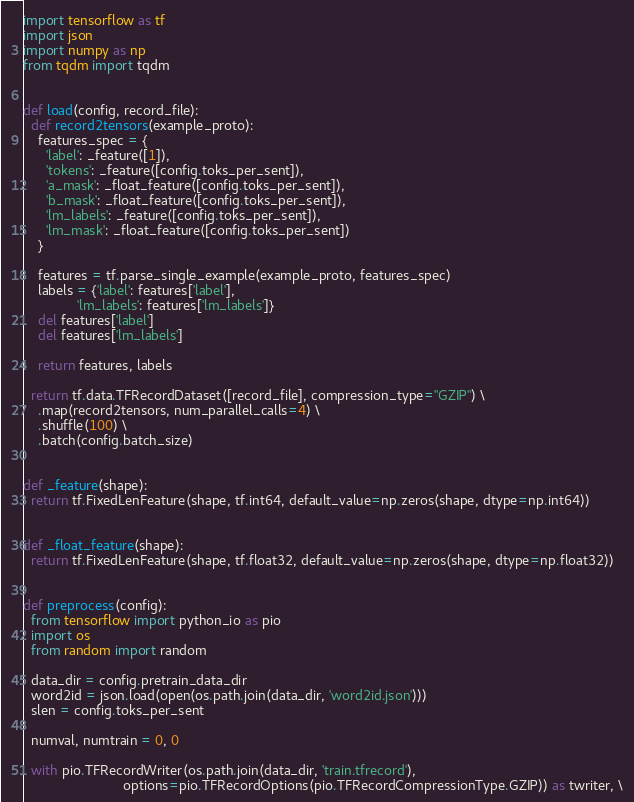<code> <loc_0><loc_0><loc_500><loc_500><_Python_>import tensorflow as tf
import json
import numpy as np
from tqdm import tqdm


def load(config, record_file):
  def record2tensors(example_proto):
    features_spec = {
      'label': _feature([1]),
      'tokens': _feature([config.toks_per_sent]),
      'a_mask': _float_feature([config.toks_per_sent]),
      'b_mask': _float_feature([config.toks_per_sent]),
      'lm_labels': _feature([config.toks_per_sent]),
      'lm_mask': _float_feature([config.toks_per_sent])
    }

    features = tf.parse_single_example(example_proto, features_spec)
    labels = {'label': features['label'],
              'lm_labels': features['lm_labels']}
    del features['label']
    del features['lm_labels']

    return features, labels

  return tf.data.TFRecordDataset([record_file], compression_type="GZIP") \
    .map(record2tensors, num_parallel_calls=4) \
    .shuffle(100) \
    .batch(config.batch_size)


def _feature(shape):
  return tf.FixedLenFeature(shape, tf.int64, default_value=np.zeros(shape, dtype=np.int64))


def _float_feature(shape):
  return tf.FixedLenFeature(shape, tf.float32, default_value=np.zeros(shape, dtype=np.float32))


def preprocess(config):
  from tensorflow import python_io as pio
  import os
  from random import random

  data_dir = config.pretrain_data_dir
  word2id = json.load(open(os.path.join(data_dir, 'word2id.json')))
  slen = config.toks_per_sent

  numval, numtrain = 0, 0

  with pio.TFRecordWriter(os.path.join(data_dir, 'train.tfrecord'),
                          options=pio.TFRecordOptions(pio.TFRecordCompressionType.GZIP)) as twriter, \</code> 